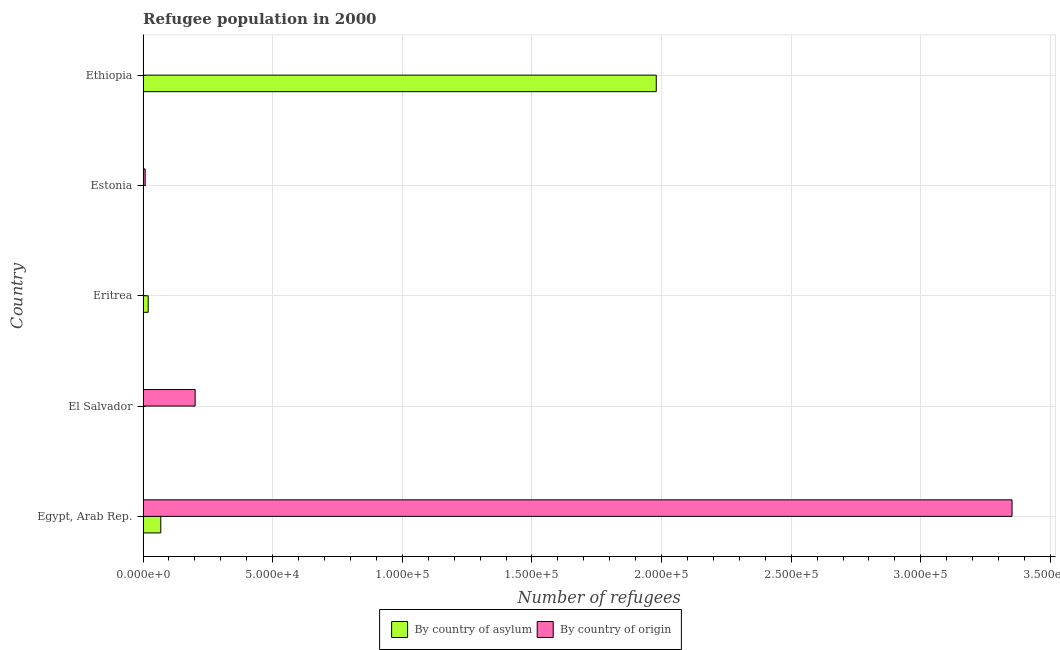How many different coloured bars are there?
Offer a terse response. 2. Are the number of bars per tick equal to the number of legend labels?
Your answer should be very brief. Yes. What is the label of the 2nd group of bars from the top?
Make the answer very short. Estonia. What is the number of refugees by country of asylum in Eritrea?
Your answer should be very brief. 1984. Across all countries, what is the maximum number of refugees by country of asylum?
Offer a very short reply. 1.98e+05. Across all countries, what is the minimum number of refugees by country of origin?
Keep it short and to the point. 11. In which country was the number of refugees by country of asylum maximum?
Provide a succinct answer. Ethiopia. In which country was the number of refugees by country of origin minimum?
Offer a terse response. Eritrea. What is the total number of refugees by country of asylum in the graph?
Keep it short and to the point. 2.07e+05. What is the difference between the number of refugees by country of origin in Egypt, Arab Rep. and that in Estonia?
Your answer should be compact. 3.34e+05. What is the difference between the number of refugees by country of asylum in Estonia and the number of refugees by country of origin in Egypt, Arab Rep.?
Make the answer very short. -3.35e+05. What is the average number of refugees by country of origin per country?
Your response must be concise. 7.12e+04. What is the difference between the number of refugees by country of origin and number of refugees by country of asylum in Egypt, Arab Rep.?
Provide a succinct answer. 3.28e+05. In how many countries, is the number of refugees by country of origin greater than 100000 ?
Your response must be concise. 1. What is the ratio of the number of refugees by country of asylum in Eritrea to that in Estonia?
Your response must be concise. 496. Is the difference between the number of refugees by country of asylum in Estonia and Ethiopia greater than the difference between the number of refugees by country of origin in Estonia and Ethiopia?
Give a very brief answer. No. What is the difference between the highest and the second highest number of refugees by country of origin?
Keep it short and to the point. 3.15e+05. What is the difference between the highest and the lowest number of refugees by country of asylum?
Your answer should be very brief. 1.98e+05. Is the sum of the number of refugees by country of origin in Egypt, Arab Rep. and El Salvador greater than the maximum number of refugees by country of asylum across all countries?
Provide a succinct answer. Yes. What does the 1st bar from the top in Eritrea represents?
Provide a short and direct response. By country of origin. What does the 1st bar from the bottom in Egypt, Arab Rep. represents?
Offer a very short reply. By country of asylum. How many countries are there in the graph?
Your response must be concise. 5. Are the values on the major ticks of X-axis written in scientific E-notation?
Your response must be concise. Yes. Does the graph contain any zero values?
Offer a very short reply. No. Does the graph contain grids?
Your response must be concise. Yes. Where does the legend appear in the graph?
Your answer should be very brief. Bottom center. How many legend labels are there?
Offer a very short reply. 2. What is the title of the graph?
Give a very brief answer. Refugee population in 2000. Does "Largest city" appear as one of the legend labels in the graph?
Offer a terse response. No. What is the label or title of the X-axis?
Provide a short and direct response. Number of refugees. What is the label or title of the Y-axis?
Make the answer very short. Country. What is the Number of refugees of By country of asylum in Egypt, Arab Rep.?
Your response must be concise. 6840. What is the Number of refugees in By country of origin in Egypt, Arab Rep.?
Your response must be concise. 3.35e+05. What is the Number of refugees of By country of asylum in El Salvador?
Your answer should be very brief. 59. What is the Number of refugees of By country of origin in El Salvador?
Give a very brief answer. 2.01e+04. What is the Number of refugees in By country of asylum in Eritrea?
Keep it short and to the point. 1984. What is the Number of refugees in By country of origin in Estonia?
Offer a very short reply. 810. What is the Number of refugees in By country of asylum in Ethiopia?
Provide a short and direct response. 1.98e+05. Across all countries, what is the maximum Number of refugees in By country of asylum?
Your answer should be very brief. 1.98e+05. Across all countries, what is the maximum Number of refugees in By country of origin?
Provide a succinct answer. 3.35e+05. What is the total Number of refugees of By country of asylum in the graph?
Your response must be concise. 2.07e+05. What is the total Number of refugees in By country of origin in the graph?
Keep it short and to the point. 3.56e+05. What is the difference between the Number of refugees in By country of asylum in Egypt, Arab Rep. and that in El Salvador?
Keep it short and to the point. 6781. What is the difference between the Number of refugees of By country of origin in Egypt, Arab Rep. and that in El Salvador?
Give a very brief answer. 3.15e+05. What is the difference between the Number of refugees in By country of asylum in Egypt, Arab Rep. and that in Eritrea?
Offer a very short reply. 4856. What is the difference between the Number of refugees in By country of origin in Egypt, Arab Rep. and that in Eritrea?
Give a very brief answer. 3.35e+05. What is the difference between the Number of refugees of By country of asylum in Egypt, Arab Rep. and that in Estonia?
Give a very brief answer. 6836. What is the difference between the Number of refugees of By country of origin in Egypt, Arab Rep. and that in Estonia?
Your answer should be compact. 3.34e+05. What is the difference between the Number of refugees of By country of asylum in Egypt, Arab Rep. and that in Ethiopia?
Provide a short and direct response. -1.91e+05. What is the difference between the Number of refugees in By country of origin in Egypt, Arab Rep. and that in Ethiopia?
Your answer should be very brief. 3.35e+05. What is the difference between the Number of refugees in By country of asylum in El Salvador and that in Eritrea?
Give a very brief answer. -1925. What is the difference between the Number of refugees of By country of origin in El Salvador and that in Eritrea?
Provide a short and direct response. 2.01e+04. What is the difference between the Number of refugees of By country of asylum in El Salvador and that in Estonia?
Give a very brief answer. 55. What is the difference between the Number of refugees in By country of origin in El Salvador and that in Estonia?
Your response must be concise. 1.93e+04. What is the difference between the Number of refugees of By country of asylum in El Salvador and that in Ethiopia?
Your answer should be very brief. -1.98e+05. What is the difference between the Number of refugees of By country of origin in El Salvador and that in Ethiopia?
Give a very brief answer. 2.01e+04. What is the difference between the Number of refugees of By country of asylum in Eritrea and that in Estonia?
Offer a very short reply. 1980. What is the difference between the Number of refugees of By country of origin in Eritrea and that in Estonia?
Your answer should be compact. -799. What is the difference between the Number of refugees of By country of asylum in Eritrea and that in Ethiopia?
Offer a terse response. -1.96e+05. What is the difference between the Number of refugees in By country of origin in Eritrea and that in Ethiopia?
Ensure brevity in your answer.  -14. What is the difference between the Number of refugees of By country of asylum in Estonia and that in Ethiopia?
Offer a terse response. -1.98e+05. What is the difference between the Number of refugees in By country of origin in Estonia and that in Ethiopia?
Ensure brevity in your answer.  785. What is the difference between the Number of refugees in By country of asylum in Egypt, Arab Rep. and the Number of refugees in By country of origin in El Salvador?
Ensure brevity in your answer.  -1.32e+04. What is the difference between the Number of refugees of By country of asylum in Egypt, Arab Rep. and the Number of refugees of By country of origin in Eritrea?
Ensure brevity in your answer.  6829. What is the difference between the Number of refugees in By country of asylum in Egypt, Arab Rep. and the Number of refugees in By country of origin in Estonia?
Keep it short and to the point. 6030. What is the difference between the Number of refugees of By country of asylum in Egypt, Arab Rep. and the Number of refugees of By country of origin in Ethiopia?
Provide a succinct answer. 6815. What is the difference between the Number of refugees in By country of asylum in El Salvador and the Number of refugees in By country of origin in Eritrea?
Offer a terse response. 48. What is the difference between the Number of refugees in By country of asylum in El Salvador and the Number of refugees in By country of origin in Estonia?
Offer a terse response. -751. What is the difference between the Number of refugees in By country of asylum in Eritrea and the Number of refugees in By country of origin in Estonia?
Provide a short and direct response. 1174. What is the difference between the Number of refugees in By country of asylum in Eritrea and the Number of refugees in By country of origin in Ethiopia?
Keep it short and to the point. 1959. What is the difference between the Number of refugees of By country of asylum in Estonia and the Number of refugees of By country of origin in Ethiopia?
Your answer should be very brief. -21. What is the average Number of refugees of By country of asylum per country?
Provide a succinct answer. 4.14e+04. What is the average Number of refugees of By country of origin per country?
Give a very brief answer. 7.12e+04. What is the difference between the Number of refugees in By country of asylum and Number of refugees in By country of origin in Egypt, Arab Rep.?
Provide a succinct answer. -3.28e+05. What is the difference between the Number of refugees in By country of asylum and Number of refugees in By country of origin in El Salvador?
Your response must be concise. -2.00e+04. What is the difference between the Number of refugees of By country of asylum and Number of refugees of By country of origin in Eritrea?
Your answer should be very brief. 1973. What is the difference between the Number of refugees in By country of asylum and Number of refugees in By country of origin in Estonia?
Offer a terse response. -806. What is the difference between the Number of refugees of By country of asylum and Number of refugees of By country of origin in Ethiopia?
Offer a very short reply. 1.98e+05. What is the ratio of the Number of refugees in By country of asylum in Egypt, Arab Rep. to that in El Salvador?
Provide a succinct answer. 115.93. What is the ratio of the Number of refugees in By country of origin in Egypt, Arab Rep. to that in El Salvador?
Offer a very short reply. 16.69. What is the ratio of the Number of refugees of By country of asylum in Egypt, Arab Rep. to that in Eritrea?
Offer a terse response. 3.45. What is the ratio of the Number of refugees in By country of origin in Egypt, Arab Rep. to that in Eritrea?
Your answer should be compact. 3.05e+04. What is the ratio of the Number of refugees of By country of asylum in Egypt, Arab Rep. to that in Estonia?
Your answer should be compact. 1710. What is the ratio of the Number of refugees in By country of origin in Egypt, Arab Rep. to that in Estonia?
Your answer should be very brief. 413.83. What is the ratio of the Number of refugees in By country of asylum in Egypt, Arab Rep. to that in Ethiopia?
Offer a terse response. 0.03. What is the ratio of the Number of refugees of By country of origin in Egypt, Arab Rep. to that in Ethiopia?
Your response must be concise. 1.34e+04. What is the ratio of the Number of refugees in By country of asylum in El Salvador to that in Eritrea?
Your response must be concise. 0.03. What is the ratio of the Number of refugees of By country of origin in El Salvador to that in Eritrea?
Provide a short and direct response. 1825.82. What is the ratio of the Number of refugees of By country of asylum in El Salvador to that in Estonia?
Your answer should be very brief. 14.75. What is the ratio of the Number of refugees of By country of origin in El Salvador to that in Estonia?
Give a very brief answer. 24.8. What is the ratio of the Number of refugees in By country of asylum in El Salvador to that in Ethiopia?
Give a very brief answer. 0. What is the ratio of the Number of refugees of By country of origin in El Salvador to that in Ethiopia?
Provide a succinct answer. 803.36. What is the ratio of the Number of refugees of By country of asylum in Eritrea to that in Estonia?
Provide a short and direct response. 496. What is the ratio of the Number of refugees in By country of origin in Eritrea to that in Estonia?
Ensure brevity in your answer.  0.01. What is the ratio of the Number of refugees in By country of origin in Eritrea to that in Ethiopia?
Offer a terse response. 0.44. What is the ratio of the Number of refugees in By country of origin in Estonia to that in Ethiopia?
Ensure brevity in your answer.  32.4. What is the difference between the highest and the second highest Number of refugees in By country of asylum?
Make the answer very short. 1.91e+05. What is the difference between the highest and the second highest Number of refugees in By country of origin?
Your response must be concise. 3.15e+05. What is the difference between the highest and the lowest Number of refugees of By country of asylum?
Give a very brief answer. 1.98e+05. What is the difference between the highest and the lowest Number of refugees of By country of origin?
Offer a very short reply. 3.35e+05. 